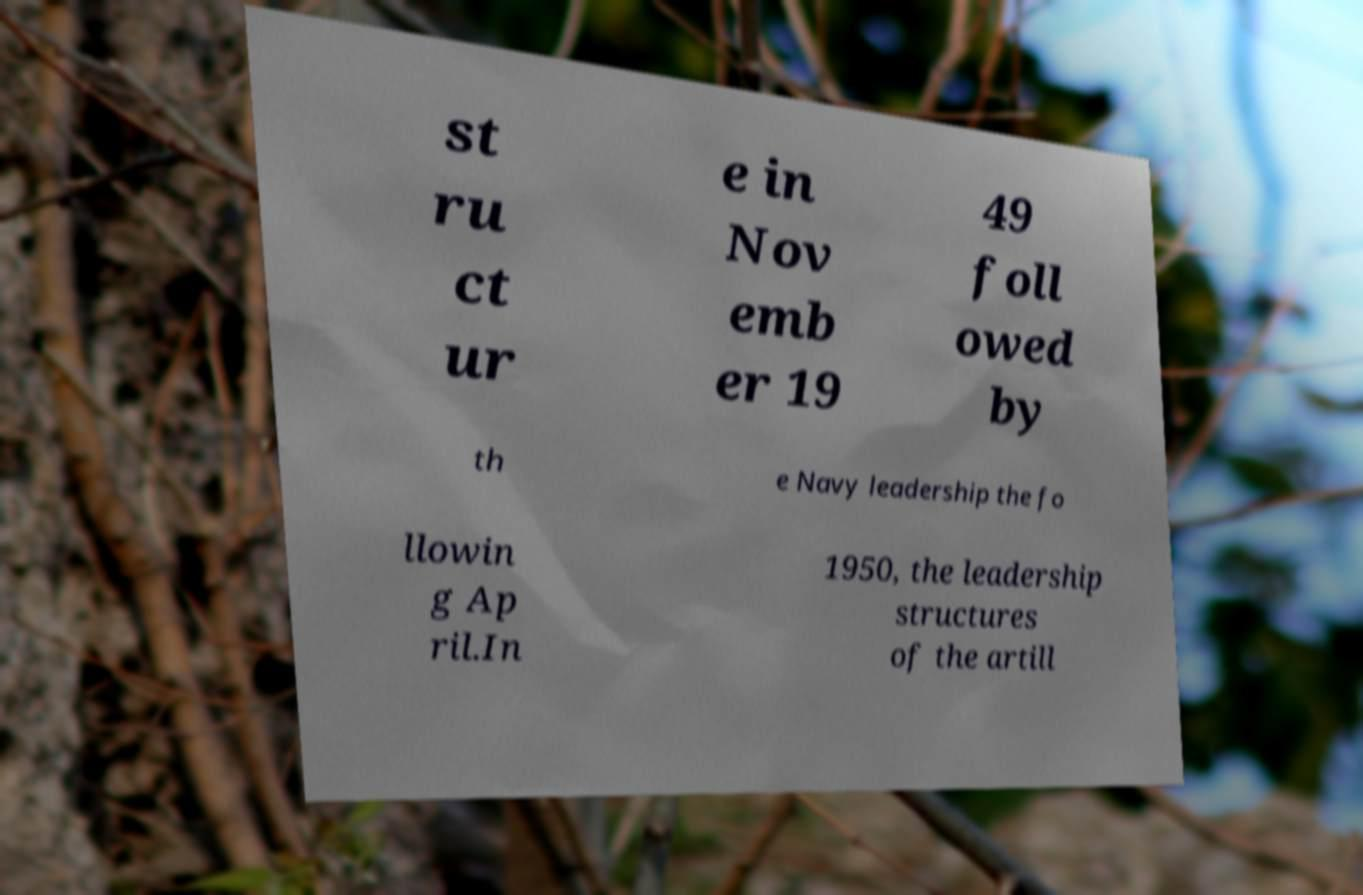There's text embedded in this image that I need extracted. Can you transcribe it verbatim? st ru ct ur e in Nov emb er 19 49 foll owed by th e Navy leadership the fo llowin g Ap ril.In 1950, the leadership structures of the artill 